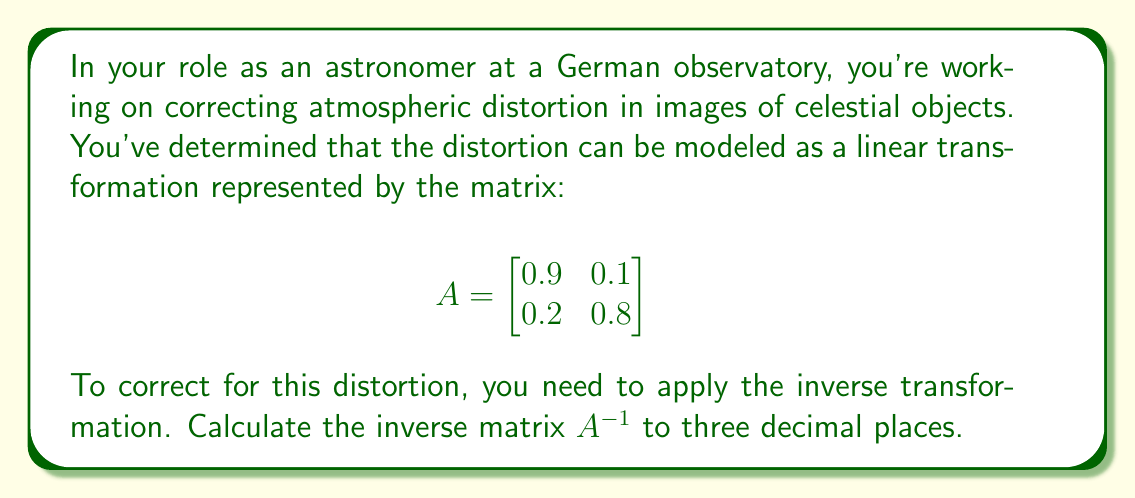Solve this math problem. To find the inverse of matrix A, we'll follow these steps:

1. Calculate the determinant of A:
   $\det(A) = (0.9)(0.8) - (0.1)(0.2) = 0.72 - 0.02 = 0.70$

2. Check if the matrix is invertible (det(A) ≠ 0):
   Since $\det(A) = 0.70 \neq 0$, the matrix is invertible.

3. Calculate the adjugate matrix:
   $$\text{adj}(A) = \begin{bmatrix}
   0.8 & -0.1 \\
   -0.2 & 0.9
   \end{bmatrix}$$

4. Apply the formula for the inverse:
   $$A^{-1} = \frac{1}{\det(A)} \cdot \text{adj}(A)$$

   $$A^{-1} = \frac{1}{0.70} \cdot \begin{bmatrix}
   0.8 & -0.1 \\
   -0.2 & 0.9
   \end{bmatrix}$$

5. Perform the scalar multiplication:
   $$A^{-1} = \begin{bmatrix}
   0.8/0.70 & -0.1/0.70 \\
   -0.2/0.70 & 0.9/0.70
   \end{bmatrix}$$

6. Calculate the final values to three decimal places:
   $$A^{-1} = \begin{bmatrix}
   1.143 & -0.143 \\
   -0.286 & 1.286
   \end{bmatrix}$$

This inverse matrix $A^{-1}$ can now be applied to correct for the atmospheric distortion in your astronomical images.
Answer: $$A^{-1} = \begin{bmatrix}
1.143 & -0.143 \\
-0.286 & 1.286
\end{bmatrix}$$ 